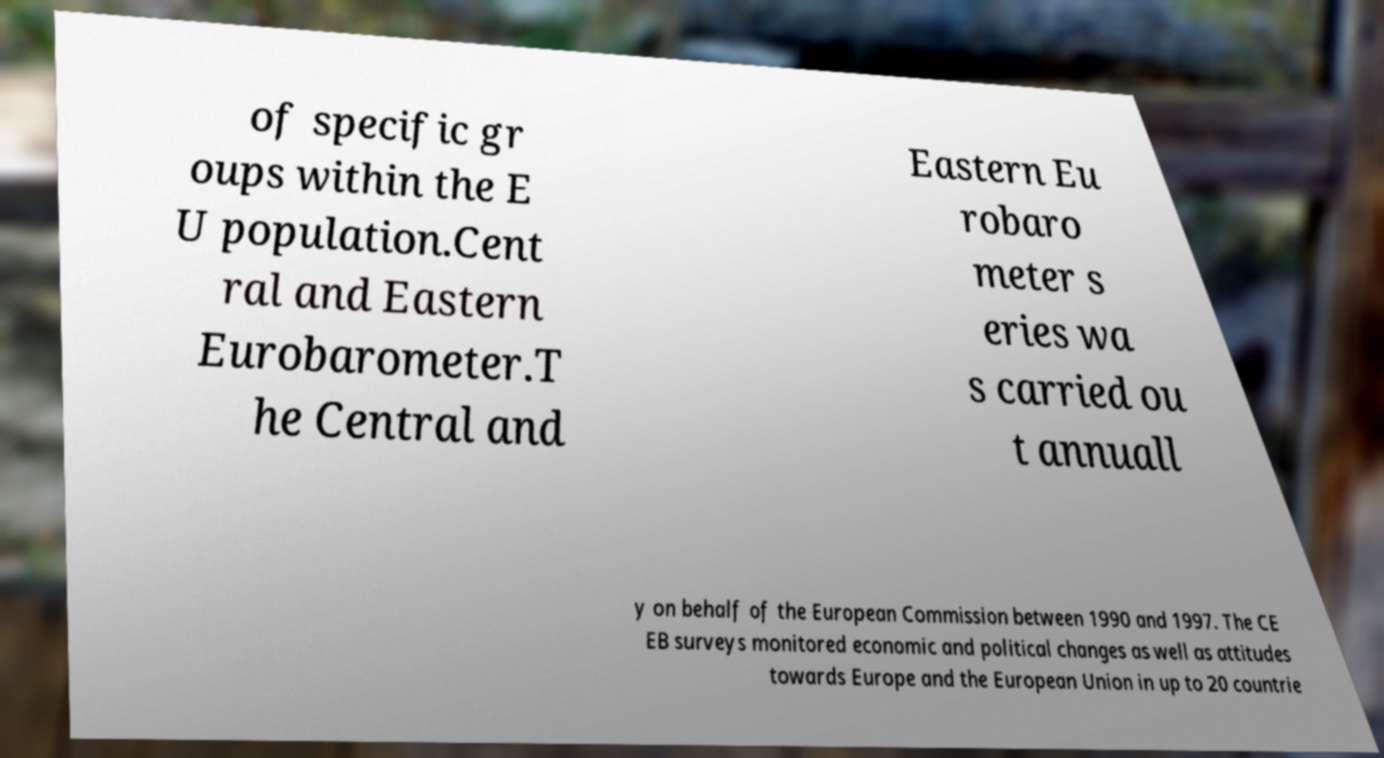For documentation purposes, I need the text within this image transcribed. Could you provide that? of specific gr oups within the E U population.Cent ral and Eastern Eurobarometer.T he Central and Eastern Eu robaro meter s eries wa s carried ou t annuall y on behalf of the European Commission between 1990 and 1997. The CE EB surveys monitored economic and political changes as well as attitudes towards Europe and the European Union in up to 20 countrie 